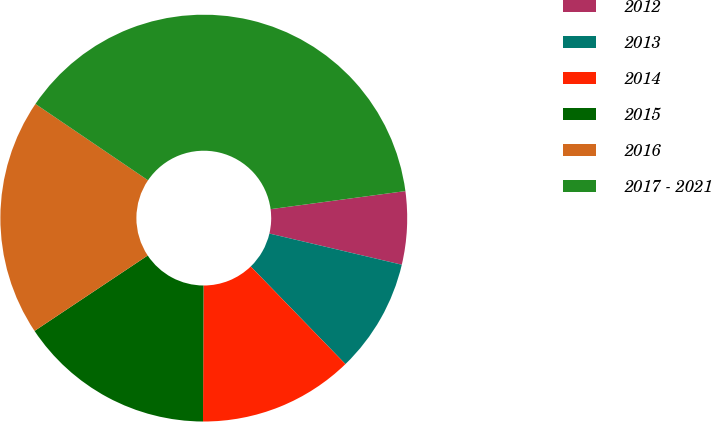Convert chart to OTSL. <chart><loc_0><loc_0><loc_500><loc_500><pie_chart><fcel>2012<fcel>2013<fcel>2014<fcel>2015<fcel>2016<fcel>2017 - 2021<nl><fcel>5.8%<fcel>9.06%<fcel>12.32%<fcel>15.58%<fcel>18.84%<fcel>38.39%<nl></chart> 